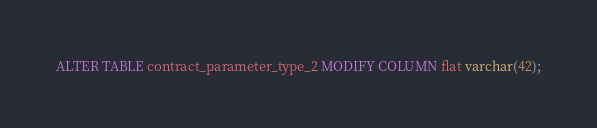<code> <loc_0><loc_0><loc_500><loc_500><_SQL_>ALTER TABLE contract_parameter_type_2 MODIFY COLUMN flat varchar(42);
</code> 